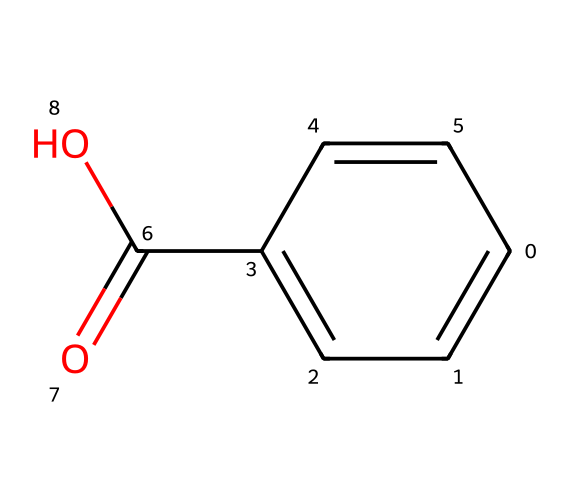What is the molecular formula of benzoic acid? To find the molecular formula, count the carbon (C), hydrogen (H), and oxygen (O) atoms in the structure. There are 7 carbon atoms, 6 hydrogen atoms, and 2 oxygen atoms, so the formula is C7H6O2.
Answer: C7H6O2 How many double bonds are present in benzoic acid? Looking at the SMILES representation, there are two double bonds: one in the carbonyl group (C=O) and multiple in the aromatic ring (C=C), making a total of three double bonds in the overall structure.
Answer: 3 What type of functional group is present in benzoic acid? The SMILES indicates a carboxylic acid functional group (-COOH), which can be identified by the presence of the carbonyl (C=O) and hydroxyl (OH) groups.
Answer: carboxylic acid What is the primary reason for the preservative qualities of benzoic acid? The carboxylic acid group (-COOH) plays a key role in its ability to inhibit microbial growth, as it can disrupt cellular processes in bacteria and fungi.
Answer: antimicrobial How many hydrogen atoms are attached to each aromatic carbon in benzoic acid? Each aromatic carbon in the benzene ring typically has one hydrogen atom attached. Since there are four carbons in the aromatic ring that each have a hydrogen and one connector to the carboxylic acid, there are four hydrogen atoms in total on those carbons.
Answer: 4 What makes benzoic acid effective as a food preservative? The presence of the carboxylic acid group allows it to be effective in preserving foods by lowering pH and preventing the growth of spoilage microorganisms, effectively enhancing its preservative qualities.
Answer: lowers pH 